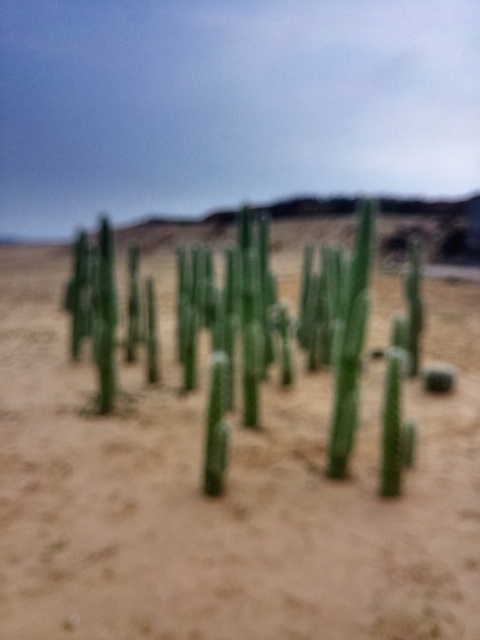Is the photo perfectly focused? The photo is not perfectly focused, as evidenced by the overall blur and lack of sharpness, particularly noticeable in the cacti that appear soft and indistinct. 